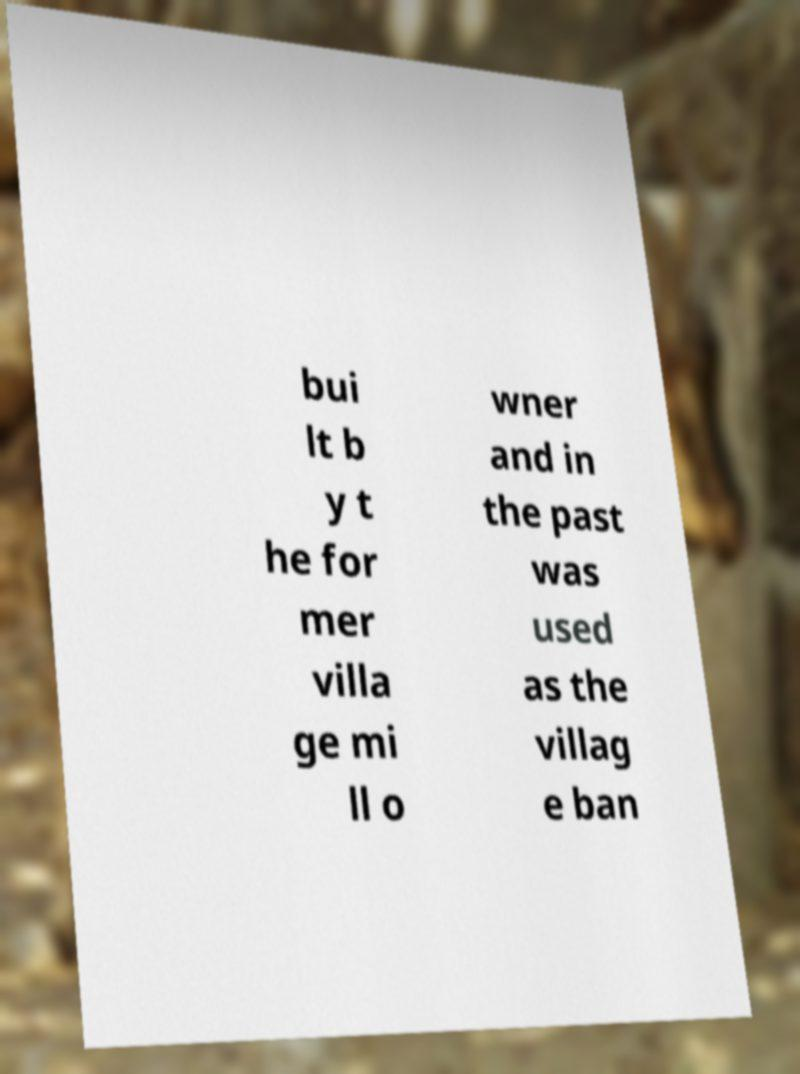What messages or text are displayed in this image? I need them in a readable, typed format. bui lt b y t he for mer villa ge mi ll o wner and in the past was used as the villag e ban 